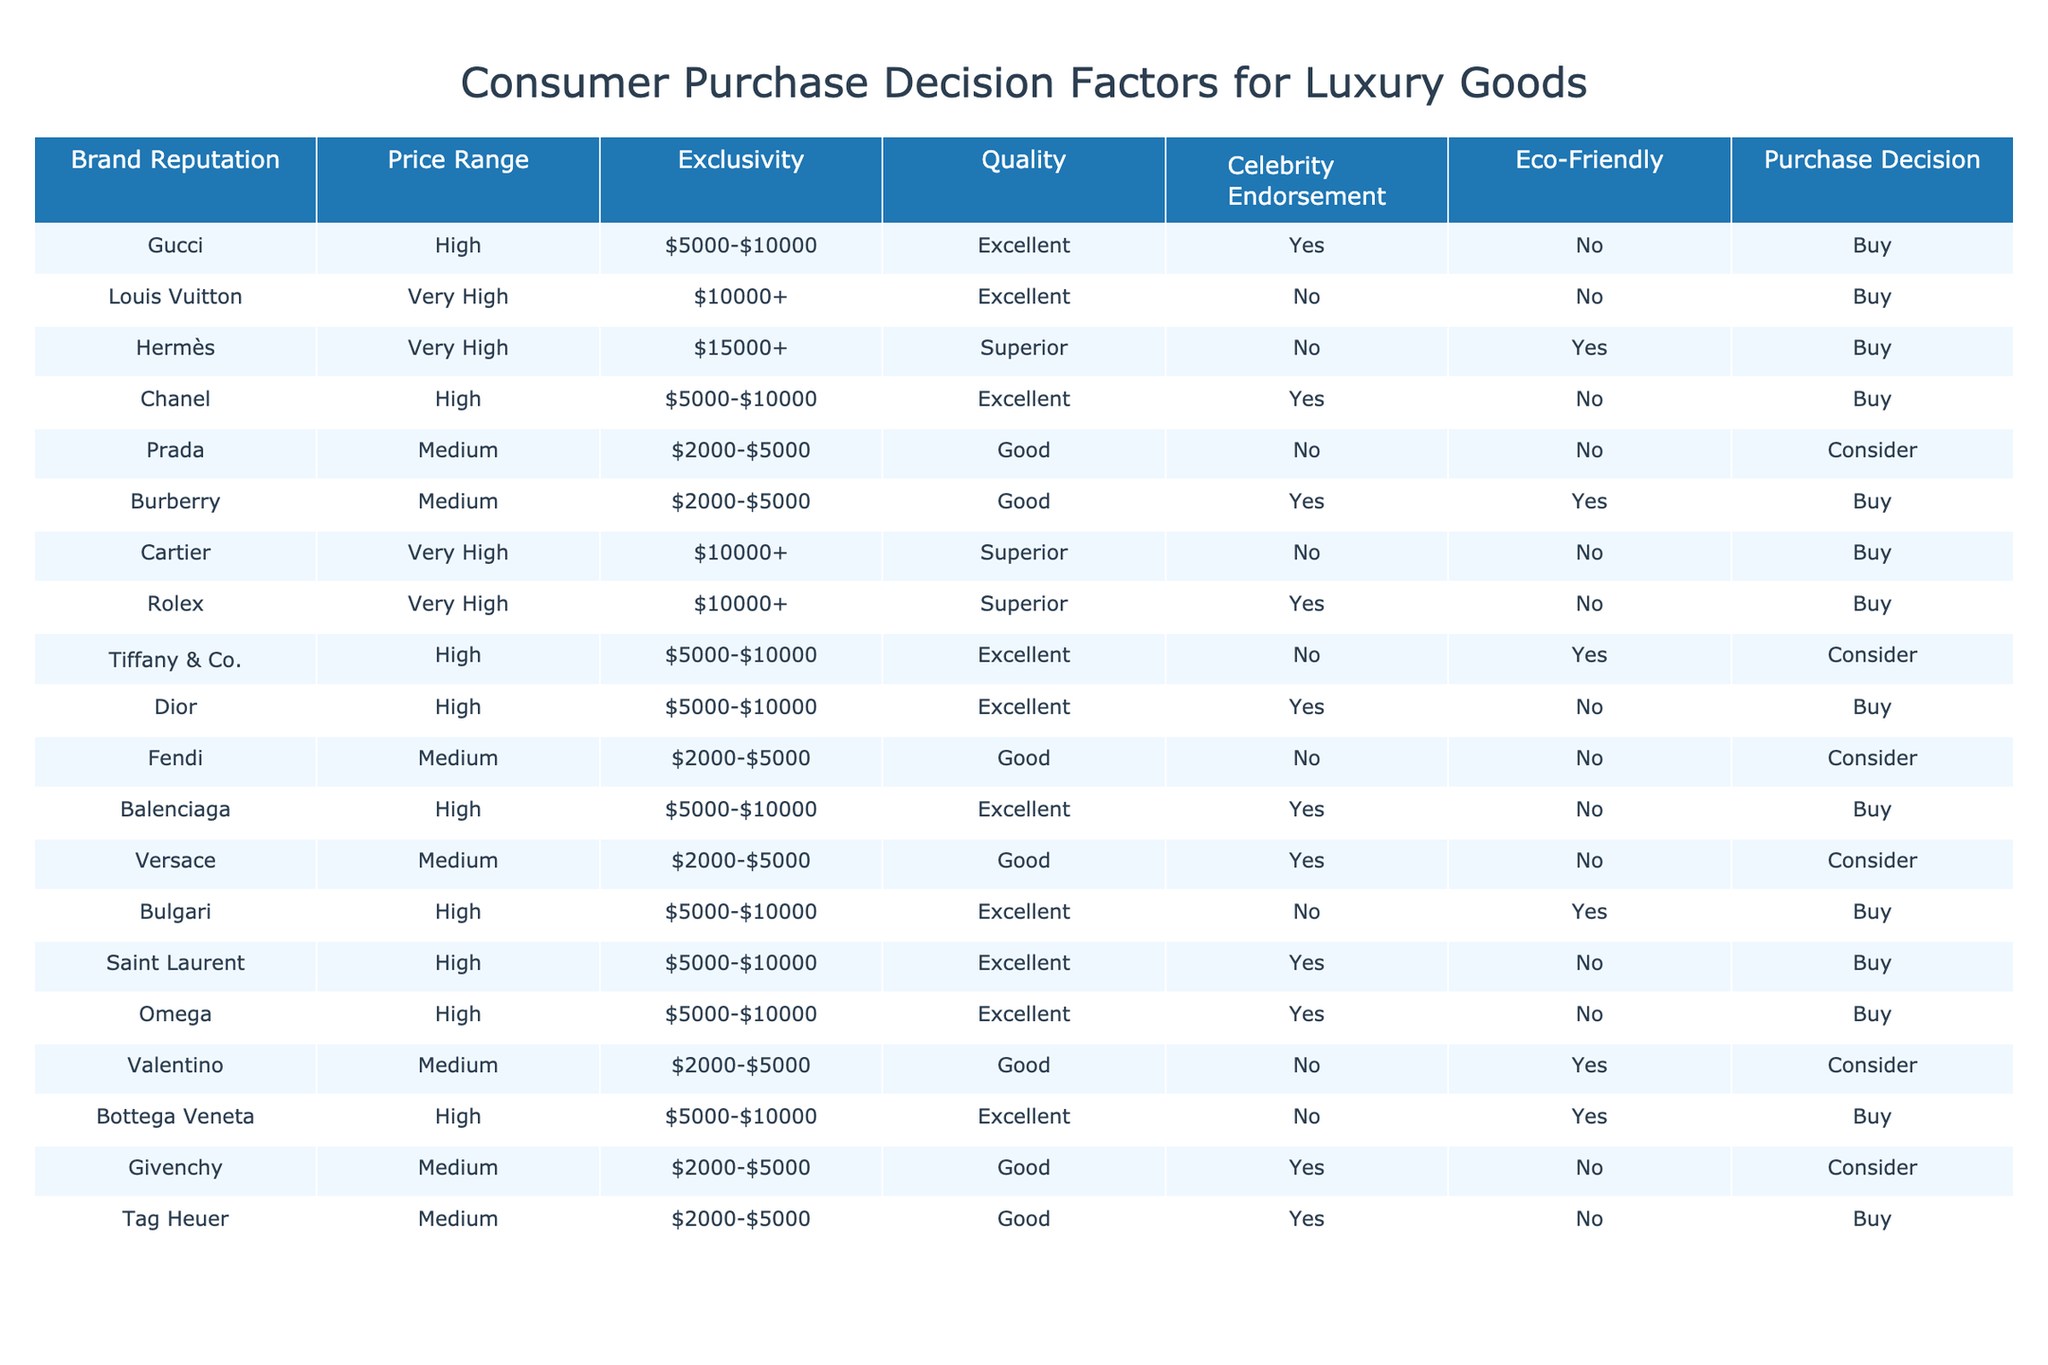What is the purchase decision for Louis Vuitton? The table indicates that for Louis Vuitton, the purchase decision is "Buy." You can find this by looking at the row corresponding to Louis Vuitton in the table.
Answer: Buy How many brands have a "High" quality rating? By scanning through the table, you can count the number of brands in the "Quality" column rated as "High." The brands with this rating are Gucci, Chanel, Dior, Balenciaga, Saint Laurent, Omega, and Bottega Veneta, making a total of 7 brands.
Answer: 7 Is there a brand that has both celebrity endorsement and is eco-friendly? Reviewing the table, you can check the columns for "Celebrity Endorsement" and "Eco-Friendly." The only brand with 'Yes' for both columns is Burberry.
Answer: Yes Which brand has the highest price range among those listed? The highest price range according to the table is indicated by "Very High" and starts from $10000+. The brands that match this criteria are Louis Vuitton, Cartier, and Rolex, each with "Very High" status. Thus, there is no single answer as multiple brands share this maximum price range.
Answer: Multiple brands (Louis Vuitton, Cartier, Rolex) What is the average price range of brands that are rated as "Consider"? The brands rated as "Consider" are Prada, Tiffany & Co., Fendi, Versace, Valentino, and Givenchy. The price ranges for these brands are $2000-$5000 for Prada, $5000-$10000 for Tiffany & Co., $2000-$5000 for Fendi, $2000-$5000 for Versace, $2000-$5000 for Valentino, and $2000-$5000 for Givenchy. The average falls between the lowest price ($2000) and highest price ($10000), resulting in an approximate average of $5000.
Answer: $5000 Are any brands within the "Medium" price range rated as "Excellent" in quality? Looking through the table, there are no brands that fall under the "Medium" price range that have an "Excellent" quality rating. Therefore, the answer is "No."
Answer: No Which brand has the best quality rating among those listed as "Buy"? The brands with the "Buy" decision are Gucci, Louis Vuitton, Hermès, Chanel, Cartier, Rolex, Dior, Balenciaga, Bulagri, Saint Laurent, Omega, and Bottega Veneta. Among these, Hermès is noted for having "Superior" quality, which is the highest rating compared to others listed as "Excellent."
Answer: Hermès If a luxury good is eco-friendly, does it always lead to a "Buy" decision? Analyzing the data shows that Burberry and Tiffany & Co. are both eco-friendly, but only Burberry has a "Buy" decision, while Tiffany & Co. has a "Consider" decision. Thus, eco-friendliness does not guarantee a "Buy" choice.
Answer: No 